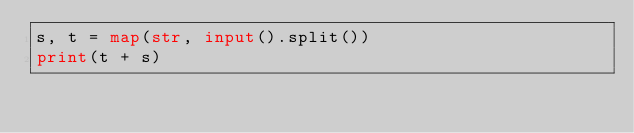<code> <loc_0><loc_0><loc_500><loc_500><_Python_>s, t = map(str, input().split())
print(t + s)</code> 